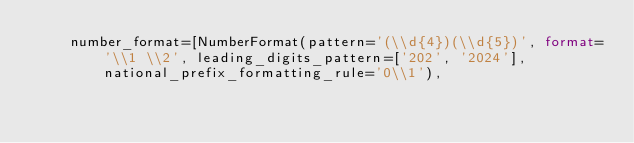<code> <loc_0><loc_0><loc_500><loc_500><_Python_>    number_format=[NumberFormat(pattern='(\\d{4})(\\d{5})', format='\\1 \\2', leading_digits_pattern=['202', '2024'], national_prefix_formatting_rule='0\\1'),</code> 